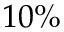<formula> <loc_0><loc_0><loc_500><loc_500>1 0 \%</formula> 